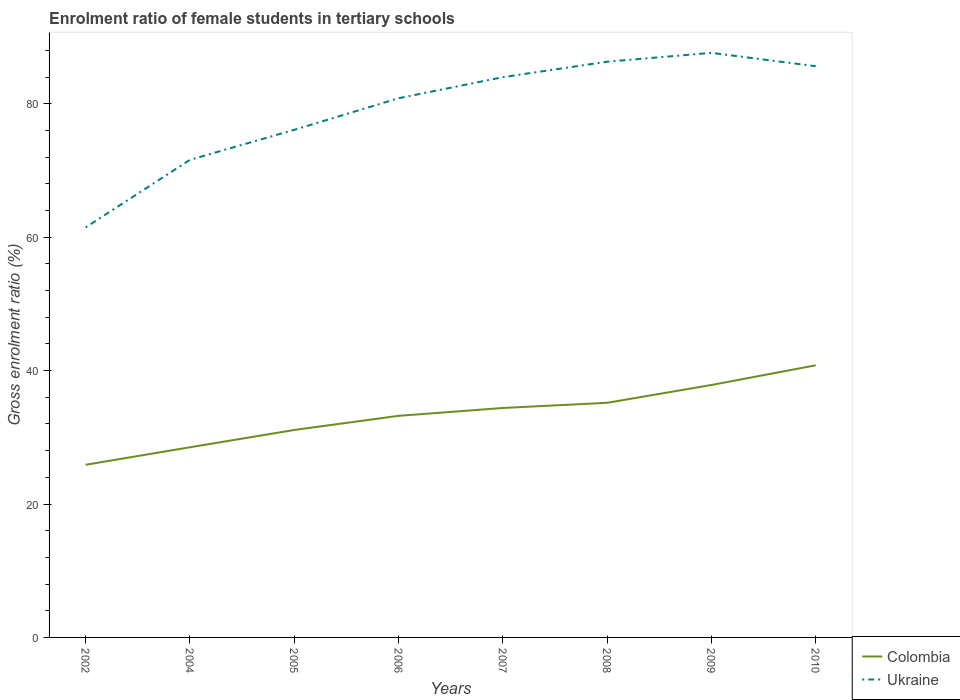Does the line corresponding to Ukraine intersect with the line corresponding to Colombia?
Provide a short and direct response. No. Across all years, what is the maximum enrolment ratio of female students in tertiary schools in Ukraine?
Your answer should be very brief. 61.46. In which year was the enrolment ratio of female students in tertiary schools in Colombia maximum?
Your answer should be very brief. 2002. What is the total enrolment ratio of female students in tertiary schools in Colombia in the graph?
Ensure brevity in your answer.  -6.74. What is the difference between the highest and the second highest enrolment ratio of female students in tertiary schools in Colombia?
Your response must be concise. 14.91. Is the enrolment ratio of female students in tertiary schools in Colombia strictly greater than the enrolment ratio of female students in tertiary schools in Ukraine over the years?
Ensure brevity in your answer.  Yes. How many years are there in the graph?
Your answer should be compact. 8. Are the values on the major ticks of Y-axis written in scientific E-notation?
Provide a succinct answer. No. Does the graph contain any zero values?
Your answer should be very brief. No. Does the graph contain grids?
Offer a very short reply. No. How are the legend labels stacked?
Offer a terse response. Vertical. What is the title of the graph?
Give a very brief answer. Enrolment ratio of female students in tertiary schools. Does "Brazil" appear as one of the legend labels in the graph?
Ensure brevity in your answer.  No. What is the label or title of the X-axis?
Your response must be concise. Years. What is the Gross enrolment ratio (%) in Colombia in 2002?
Keep it short and to the point. 25.88. What is the Gross enrolment ratio (%) in Ukraine in 2002?
Offer a very short reply. 61.46. What is the Gross enrolment ratio (%) in Colombia in 2004?
Make the answer very short. 28.51. What is the Gross enrolment ratio (%) of Ukraine in 2004?
Provide a short and direct response. 71.59. What is the Gross enrolment ratio (%) in Colombia in 2005?
Provide a succinct answer. 31.1. What is the Gross enrolment ratio (%) of Ukraine in 2005?
Offer a terse response. 76.09. What is the Gross enrolment ratio (%) of Colombia in 2006?
Your answer should be very brief. 33.22. What is the Gross enrolment ratio (%) of Ukraine in 2006?
Your answer should be very brief. 80.82. What is the Gross enrolment ratio (%) of Colombia in 2007?
Ensure brevity in your answer.  34.39. What is the Gross enrolment ratio (%) in Ukraine in 2007?
Your answer should be very brief. 83.98. What is the Gross enrolment ratio (%) in Colombia in 2008?
Provide a short and direct response. 35.17. What is the Gross enrolment ratio (%) of Ukraine in 2008?
Your response must be concise. 86.3. What is the Gross enrolment ratio (%) of Colombia in 2009?
Provide a short and direct response. 37.84. What is the Gross enrolment ratio (%) of Ukraine in 2009?
Your answer should be very brief. 87.63. What is the Gross enrolment ratio (%) of Colombia in 2010?
Your response must be concise. 40.79. What is the Gross enrolment ratio (%) of Ukraine in 2010?
Give a very brief answer. 85.63. Across all years, what is the maximum Gross enrolment ratio (%) of Colombia?
Give a very brief answer. 40.79. Across all years, what is the maximum Gross enrolment ratio (%) in Ukraine?
Your answer should be very brief. 87.63. Across all years, what is the minimum Gross enrolment ratio (%) of Colombia?
Your answer should be compact. 25.88. Across all years, what is the minimum Gross enrolment ratio (%) of Ukraine?
Offer a very short reply. 61.46. What is the total Gross enrolment ratio (%) in Colombia in the graph?
Keep it short and to the point. 266.88. What is the total Gross enrolment ratio (%) of Ukraine in the graph?
Offer a terse response. 633.49. What is the difference between the Gross enrolment ratio (%) of Colombia in 2002 and that in 2004?
Your answer should be very brief. -2.63. What is the difference between the Gross enrolment ratio (%) of Ukraine in 2002 and that in 2004?
Your response must be concise. -10.13. What is the difference between the Gross enrolment ratio (%) of Colombia in 2002 and that in 2005?
Your response must be concise. -5.22. What is the difference between the Gross enrolment ratio (%) in Ukraine in 2002 and that in 2005?
Provide a short and direct response. -14.63. What is the difference between the Gross enrolment ratio (%) in Colombia in 2002 and that in 2006?
Provide a short and direct response. -7.34. What is the difference between the Gross enrolment ratio (%) in Ukraine in 2002 and that in 2006?
Provide a short and direct response. -19.36. What is the difference between the Gross enrolment ratio (%) of Colombia in 2002 and that in 2007?
Provide a succinct answer. -8.52. What is the difference between the Gross enrolment ratio (%) in Ukraine in 2002 and that in 2007?
Offer a terse response. -22.52. What is the difference between the Gross enrolment ratio (%) in Colombia in 2002 and that in 2008?
Provide a succinct answer. -9.29. What is the difference between the Gross enrolment ratio (%) of Ukraine in 2002 and that in 2008?
Keep it short and to the point. -24.84. What is the difference between the Gross enrolment ratio (%) of Colombia in 2002 and that in 2009?
Provide a short and direct response. -11.96. What is the difference between the Gross enrolment ratio (%) of Ukraine in 2002 and that in 2009?
Your response must be concise. -26.17. What is the difference between the Gross enrolment ratio (%) in Colombia in 2002 and that in 2010?
Ensure brevity in your answer.  -14.91. What is the difference between the Gross enrolment ratio (%) of Ukraine in 2002 and that in 2010?
Make the answer very short. -24.16. What is the difference between the Gross enrolment ratio (%) of Colombia in 2004 and that in 2005?
Give a very brief answer. -2.59. What is the difference between the Gross enrolment ratio (%) in Ukraine in 2004 and that in 2005?
Offer a very short reply. -4.5. What is the difference between the Gross enrolment ratio (%) in Colombia in 2004 and that in 2006?
Give a very brief answer. -4.71. What is the difference between the Gross enrolment ratio (%) of Ukraine in 2004 and that in 2006?
Make the answer very short. -9.23. What is the difference between the Gross enrolment ratio (%) in Colombia in 2004 and that in 2007?
Your response must be concise. -5.89. What is the difference between the Gross enrolment ratio (%) of Ukraine in 2004 and that in 2007?
Your answer should be compact. -12.39. What is the difference between the Gross enrolment ratio (%) in Colombia in 2004 and that in 2008?
Provide a short and direct response. -6.66. What is the difference between the Gross enrolment ratio (%) of Ukraine in 2004 and that in 2008?
Offer a terse response. -14.71. What is the difference between the Gross enrolment ratio (%) in Colombia in 2004 and that in 2009?
Offer a very short reply. -9.33. What is the difference between the Gross enrolment ratio (%) of Ukraine in 2004 and that in 2009?
Offer a terse response. -16.04. What is the difference between the Gross enrolment ratio (%) in Colombia in 2004 and that in 2010?
Provide a short and direct response. -12.28. What is the difference between the Gross enrolment ratio (%) of Ukraine in 2004 and that in 2010?
Give a very brief answer. -14.04. What is the difference between the Gross enrolment ratio (%) of Colombia in 2005 and that in 2006?
Your answer should be compact. -2.12. What is the difference between the Gross enrolment ratio (%) in Ukraine in 2005 and that in 2006?
Provide a short and direct response. -4.73. What is the difference between the Gross enrolment ratio (%) in Colombia in 2005 and that in 2007?
Offer a very short reply. -3.3. What is the difference between the Gross enrolment ratio (%) of Ukraine in 2005 and that in 2007?
Provide a succinct answer. -7.89. What is the difference between the Gross enrolment ratio (%) of Colombia in 2005 and that in 2008?
Make the answer very short. -4.07. What is the difference between the Gross enrolment ratio (%) of Ukraine in 2005 and that in 2008?
Ensure brevity in your answer.  -10.21. What is the difference between the Gross enrolment ratio (%) of Colombia in 2005 and that in 2009?
Offer a very short reply. -6.74. What is the difference between the Gross enrolment ratio (%) in Ukraine in 2005 and that in 2009?
Your response must be concise. -11.54. What is the difference between the Gross enrolment ratio (%) in Colombia in 2005 and that in 2010?
Make the answer very short. -9.69. What is the difference between the Gross enrolment ratio (%) of Ukraine in 2005 and that in 2010?
Keep it short and to the point. -9.54. What is the difference between the Gross enrolment ratio (%) of Colombia in 2006 and that in 2007?
Offer a terse response. -1.18. What is the difference between the Gross enrolment ratio (%) of Ukraine in 2006 and that in 2007?
Give a very brief answer. -3.16. What is the difference between the Gross enrolment ratio (%) in Colombia in 2006 and that in 2008?
Give a very brief answer. -1.95. What is the difference between the Gross enrolment ratio (%) of Ukraine in 2006 and that in 2008?
Your answer should be compact. -5.48. What is the difference between the Gross enrolment ratio (%) in Colombia in 2006 and that in 2009?
Offer a terse response. -4.62. What is the difference between the Gross enrolment ratio (%) of Ukraine in 2006 and that in 2009?
Offer a terse response. -6.8. What is the difference between the Gross enrolment ratio (%) of Colombia in 2006 and that in 2010?
Offer a very short reply. -7.57. What is the difference between the Gross enrolment ratio (%) of Ukraine in 2006 and that in 2010?
Your response must be concise. -4.8. What is the difference between the Gross enrolment ratio (%) of Colombia in 2007 and that in 2008?
Provide a short and direct response. -0.77. What is the difference between the Gross enrolment ratio (%) in Ukraine in 2007 and that in 2008?
Give a very brief answer. -2.32. What is the difference between the Gross enrolment ratio (%) of Colombia in 2007 and that in 2009?
Provide a short and direct response. -3.45. What is the difference between the Gross enrolment ratio (%) in Ukraine in 2007 and that in 2009?
Your answer should be compact. -3.64. What is the difference between the Gross enrolment ratio (%) in Colombia in 2007 and that in 2010?
Make the answer very short. -6.4. What is the difference between the Gross enrolment ratio (%) of Ukraine in 2007 and that in 2010?
Provide a short and direct response. -1.64. What is the difference between the Gross enrolment ratio (%) of Colombia in 2008 and that in 2009?
Give a very brief answer. -2.67. What is the difference between the Gross enrolment ratio (%) of Ukraine in 2008 and that in 2009?
Provide a succinct answer. -1.33. What is the difference between the Gross enrolment ratio (%) in Colombia in 2008 and that in 2010?
Your answer should be very brief. -5.62. What is the difference between the Gross enrolment ratio (%) in Ukraine in 2008 and that in 2010?
Ensure brevity in your answer.  0.67. What is the difference between the Gross enrolment ratio (%) of Colombia in 2009 and that in 2010?
Make the answer very short. -2.95. What is the difference between the Gross enrolment ratio (%) of Ukraine in 2009 and that in 2010?
Ensure brevity in your answer.  2. What is the difference between the Gross enrolment ratio (%) in Colombia in 2002 and the Gross enrolment ratio (%) in Ukraine in 2004?
Your answer should be very brief. -45.71. What is the difference between the Gross enrolment ratio (%) in Colombia in 2002 and the Gross enrolment ratio (%) in Ukraine in 2005?
Your response must be concise. -50.21. What is the difference between the Gross enrolment ratio (%) of Colombia in 2002 and the Gross enrolment ratio (%) of Ukraine in 2006?
Make the answer very short. -54.94. What is the difference between the Gross enrolment ratio (%) of Colombia in 2002 and the Gross enrolment ratio (%) of Ukraine in 2007?
Ensure brevity in your answer.  -58.1. What is the difference between the Gross enrolment ratio (%) of Colombia in 2002 and the Gross enrolment ratio (%) of Ukraine in 2008?
Your answer should be compact. -60.42. What is the difference between the Gross enrolment ratio (%) of Colombia in 2002 and the Gross enrolment ratio (%) of Ukraine in 2009?
Offer a terse response. -61.75. What is the difference between the Gross enrolment ratio (%) in Colombia in 2002 and the Gross enrolment ratio (%) in Ukraine in 2010?
Provide a succinct answer. -59.75. What is the difference between the Gross enrolment ratio (%) of Colombia in 2004 and the Gross enrolment ratio (%) of Ukraine in 2005?
Offer a terse response. -47.58. What is the difference between the Gross enrolment ratio (%) in Colombia in 2004 and the Gross enrolment ratio (%) in Ukraine in 2006?
Provide a succinct answer. -52.32. What is the difference between the Gross enrolment ratio (%) in Colombia in 2004 and the Gross enrolment ratio (%) in Ukraine in 2007?
Your answer should be very brief. -55.48. What is the difference between the Gross enrolment ratio (%) in Colombia in 2004 and the Gross enrolment ratio (%) in Ukraine in 2008?
Make the answer very short. -57.79. What is the difference between the Gross enrolment ratio (%) in Colombia in 2004 and the Gross enrolment ratio (%) in Ukraine in 2009?
Your answer should be compact. -59.12. What is the difference between the Gross enrolment ratio (%) in Colombia in 2004 and the Gross enrolment ratio (%) in Ukraine in 2010?
Make the answer very short. -57.12. What is the difference between the Gross enrolment ratio (%) in Colombia in 2005 and the Gross enrolment ratio (%) in Ukraine in 2006?
Keep it short and to the point. -49.73. What is the difference between the Gross enrolment ratio (%) in Colombia in 2005 and the Gross enrolment ratio (%) in Ukraine in 2007?
Ensure brevity in your answer.  -52.89. What is the difference between the Gross enrolment ratio (%) of Colombia in 2005 and the Gross enrolment ratio (%) of Ukraine in 2008?
Make the answer very short. -55.2. What is the difference between the Gross enrolment ratio (%) in Colombia in 2005 and the Gross enrolment ratio (%) in Ukraine in 2009?
Your answer should be compact. -56.53. What is the difference between the Gross enrolment ratio (%) of Colombia in 2005 and the Gross enrolment ratio (%) of Ukraine in 2010?
Keep it short and to the point. -54.53. What is the difference between the Gross enrolment ratio (%) in Colombia in 2006 and the Gross enrolment ratio (%) in Ukraine in 2007?
Offer a terse response. -50.77. What is the difference between the Gross enrolment ratio (%) in Colombia in 2006 and the Gross enrolment ratio (%) in Ukraine in 2008?
Your answer should be compact. -53.08. What is the difference between the Gross enrolment ratio (%) in Colombia in 2006 and the Gross enrolment ratio (%) in Ukraine in 2009?
Provide a succinct answer. -54.41. What is the difference between the Gross enrolment ratio (%) of Colombia in 2006 and the Gross enrolment ratio (%) of Ukraine in 2010?
Your response must be concise. -52.41. What is the difference between the Gross enrolment ratio (%) in Colombia in 2007 and the Gross enrolment ratio (%) in Ukraine in 2008?
Give a very brief answer. -51.91. What is the difference between the Gross enrolment ratio (%) of Colombia in 2007 and the Gross enrolment ratio (%) of Ukraine in 2009?
Ensure brevity in your answer.  -53.23. What is the difference between the Gross enrolment ratio (%) in Colombia in 2007 and the Gross enrolment ratio (%) in Ukraine in 2010?
Provide a short and direct response. -51.23. What is the difference between the Gross enrolment ratio (%) of Colombia in 2008 and the Gross enrolment ratio (%) of Ukraine in 2009?
Your answer should be very brief. -52.46. What is the difference between the Gross enrolment ratio (%) of Colombia in 2008 and the Gross enrolment ratio (%) of Ukraine in 2010?
Give a very brief answer. -50.46. What is the difference between the Gross enrolment ratio (%) in Colombia in 2009 and the Gross enrolment ratio (%) in Ukraine in 2010?
Your response must be concise. -47.79. What is the average Gross enrolment ratio (%) in Colombia per year?
Keep it short and to the point. 33.36. What is the average Gross enrolment ratio (%) in Ukraine per year?
Offer a very short reply. 79.19. In the year 2002, what is the difference between the Gross enrolment ratio (%) of Colombia and Gross enrolment ratio (%) of Ukraine?
Offer a very short reply. -35.58. In the year 2004, what is the difference between the Gross enrolment ratio (%) in Colombia and Gross enrolment ratio (%) in Ukraine?
Your answer should be very brief. -43.08. In the year 2005, what is the difference between the Gross enrolment ratio (%) of Colombia and Gross enrolment ratio (%) of Ukraine?
Ensure brevity in your answer.  -44.99. In the year 2006, what is the difference between the Gross enrolment ratio (%) of Colombia and Gross enrolment ratio (%) of Ukraine?
Your response must be concise. -47.61. In the year 2007, what is the difference between the Gross enrolment ratio (%) in Colombia and Gross enrolment ratio (%) in Ukraine?
Your answer should be compact. -49.59. In the year 2008, what is the difference between the Gross enrolment ratio (%) in Colombia and Gross enrolment ratio (%) in Ukraine?
Keep it short and to the point. -51.13. In the year 2009, what is the difference between the Gross enrolment ratio (%) of Colombia and Gross enrolment ratio (%) of Ukraine?
Your answer should be compact. -49.79. In the year 2010, what is the difference between the Gross enrolment ratio (%) in Colombia and Gross enrolment ratio (%) in Ukraine?
Offer a very short reply. -44.84. What is the ratio of the Gross enrolment ratio (%) of Colombia in 2002 to that in 2004?
Offer a terse response. 0.91. What is the ratio of the Gross enrolment ratio (%) in Ukraine in 2002 to that in 2004?
Offer a very short reply. 0.86. What is the ratio of the Gross enrolment ratio (%) in Colombia in 2002 to that in 2005?
Make the answer very short. 0.83. What is the ratio of the Gross enrolment ratio (%) in Ukraine in 2002 to that in 2005?
Keep it short and to the point. 0.81. What is the ratio of the Gross enrolment ratio (%) of Colombia in 2002 to that in 2006?
Provide a succinct answer. 0.78. What is the ratio of the Gross enrolment ratio (%) of Ukraine in 2002 to that in 2006?
Offer a terse response. 0.76. What is the ratio of the Gross enrolment ratio (%) in Colombia in 2002 to that in 2007?
Ensure brevity in your answer.  0.75. What is the ratio of the Gross enrolment ratio (%) in Ukraine in 2002 to that in 2007?
Provide a short and direct response. 0.73. What is the ratio of the Gross enrolment ratio (%) of Colombia in 2002 to that in 2008?
Your answer should be very brief. 0.74. What is the ratio of the Gross enrolment ratio (%) in Ukraine in 2002 to that in 2008?
Make the answer very short. 0.71. What is the ratio of the Gross enrolment ratio (%) of Colombia in 2002 to that in 2009?
Give a very brief answer. 0.68. What is the ratio of the Gross enrolment ratio (%) in Ukraine in 2002 to that in 2009?
Provide a succinct answer. 0.7. What is the ratio of the Gross enrolment ratio (%) in Colombia in 2002 to that in 2010?
Ensure brevity in your answer.  0.63. What is the ratio of the Gross enrolment ratio (%) in Ukraine in 2002 to that in 2010?
Your answer should be compact. 0.72. What is the ratio of the Gross enrolment ratio (%) in Colombia in 2004 to that in 2005?
Offer a very short reply. 0.92. What is the ratio of the Gross enrolment ratio (%) of Ukraine in 2004 to that in 2005?
Make the answer very short. 0.94. What is the ratio of the Gross enrolment ratio (%) in Colombia in 2004 to that in 2006?
Your response must be concise. 0.86. What is the ratio of the Gross enrolment ratio (%) in Ukraine in 2004 to that in 2006?
Make the answer very short. 0.89. What is the ratio of the Gross enrolment ratio (%) in Colombia in 2004 to that in 2007?
Your answer should be very brief. 0.83. What is the ratio of the Gross enrolment ratio (%) of Ukraine in 2004 to that in 2007?
Offer a terse response. 0.85. What is the ratio of the Gross enrolment ratio (%) in Colombia in 2004 to that in 2008?
Give a very brief answer. 0.81. What is the ratio of the Gross enrolment ratio (%) of Ukraine in 2004 to that in 2008?
Provide a succinct answer. 0.83. What is the ratio of the Gross enrolment ratio (%) of Colombia in 2004 to that in 2009?
Provide a succinct answer. 0.75. What is the ratio of the Gross enrolment ratio (%) of Ukraine in 2004 to that in 2009?
Your answer should be compact. 0.82. What is the ratio of the Gross enrolment ratio (%) of Colombia in 2004 to that in 2010?
Offer a terse response. 0.7. What is the ratio of the Gross enrolment ratio (%) in Ukraine in 2004 to that in 2010?
Offer a very short reply. 0.84. What is the ratio of the Gross enrolment ratio (%) of Colombia in 2005 to that in 2006?
Keep it short and to the point. 0.94. What is the ratio of the Gross enrolment ratio (%) of Ukraine in 2005 to that in 2006?
Your response must be concise. 0.94. What is the ratio of the Gross enrolment ratio (%) in Colombia in 2005 to that in 2007?
Your answer should be compact. 0.9. What is the ratio of the Gross enrolment ratio (%) of Ukraine in 2005 to that in 2007?
Provide a short and direct response. 0.91. What is the ratio of the Gross enrolment ratio (%) in Colombia in 2005 to that in 2008?
Your answer should be very brief. 0.88. What is the ratio of the Gross enrolment ratio (%) in Ukraine in 2005 to that in 2008?
Provide a succinct answer. 0.88. What is the ratio of the Gross enrolment ratio (%) in Colombia in 2005 to that in 2009?
Give a very brief answer. 0.82. What is the ratio of the Gross enrolment ratio (%) in Ukraine in 2005 to that in 2009?
Offer a terse response. 0.87. What is the ratio of the Gross enrolment ratio (%) in Colombia in 2005 to that in 2010?
Give a very brief answer. 0.76. What is the ratio of the Gross enrolment ratio (%) of Ukraine in 2005 to that in 2010?
Your answer should be compact. 0.89. What is the ratio of the Gross enrolment ratio (%) in Colombia in 2006 to that in 2007?
Provide a short and direct response. 0.97. What is the ratio of the Gross enrolment ratio (%) in Ukraine in 2006 to that in 2007?
Your response must be concise. 0.96. What is the ratio of the Gross enrolment ratio (%) of Colombia in 2006 to that in 2008?
Your response must be concise. 0.94. What is the ratio of the Gross enrolment ratio (%) in Ukraine in 2006 to that in 2008?
Your response must be concise. 0.94. What is the ratio of the Gross enrolment ratio (%) of Colombia in 2006 to that in 2009?
Your answer should be compact. 0.88. What is the ratio of the Gross enrolment ratio (%) of Ukraine in 2006 to that in 2009?
Offer a terse response. 0.92. What is the ratio of the Gross enrolment ratio (%) in Colombia in 2006 to that in 2010?
Make the answer very short. 0.81. What is the ratio of the Gross enrolment ratio (%) of Ukraine in 2006 to that in 2010?
Provide a succinct answer. 0.94. What is the ratio of the Gross enrolment ratio (%) in Ukraine in 2007 to that in 2008?
Ensure brevity in your answer.  0.97. What is the ratio of the Gross enrolment ratio (%) in Colombia in 2007 to that in 2009?
Make the answer very short. 0.91. What is the ratio of the Gross enrolment ratio (%) in Ukraine in 2007 to that in 2009?
Offer a terse response. 0.96. What is the ratio of the Gross enrolment ratio (%) of Colombia in 2007 to that in 2010?
Give a very brief answer. 0.84. What is the ratio of the Gross enrolment ratio (%) of Ukraine in 2007 to that in 2010?
Your response must be concise. 0.98. What is the ratio of the Gross enrolment ratio (%) of Colombia in 2008 to that in 2009?
Offer a very short reply. 0.93. What is the ratio of the Gross enrolment ratio (%) in Ukraine in 2008 to that in 2009?
Your answer should be very brief. 0.98. What is the ratio of the Gross enrolment ratio (%) of Colombia in 2008 to that in 2010?
Your response must be concise. 0.86. What is the ratio of the Gross enrolment ratio (%) in Ukraine in 2008 to that in 2010?
Make the answer very short. 1.01. What is the ratio of the Gross enrolment ratio (%) in Colombia in 2009 to that in 2010?
Your answer should be compact. 0.93. What is the ratio of the Gross enrolment ratio (%) of Ukraine in 2009 to that in 2010?
Give a very brief answer. 1.02. What is the difference between the highest and the second highest Gross enrolment ratio (%) of Colombia?
Your response must be concise. 2.95. What is the difference between the highest and the second highest Gross enrolment ratio (%) of Ukraine?
Provide a short and direct response. 1.33. What is the difference between the highest and the lowest Gross enrolment ratio (%) of Colombia?
Give a very brief answer. 14.91. What is the difference between the highest and the lowest Gross enrolment ratio (%) of Ukraine?
Your answer should be very brief. 26.17. 